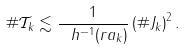<formula> <loc_0><loc_0><loc_500><loc_500>\# \mathcal { T } _ { k } \lesssim \frac { 1 } { \ h ^ { - 1 } ( r a _ { k } ) } \left ( \# J _ { k } \right ) ^ { 2 } .</formula> 